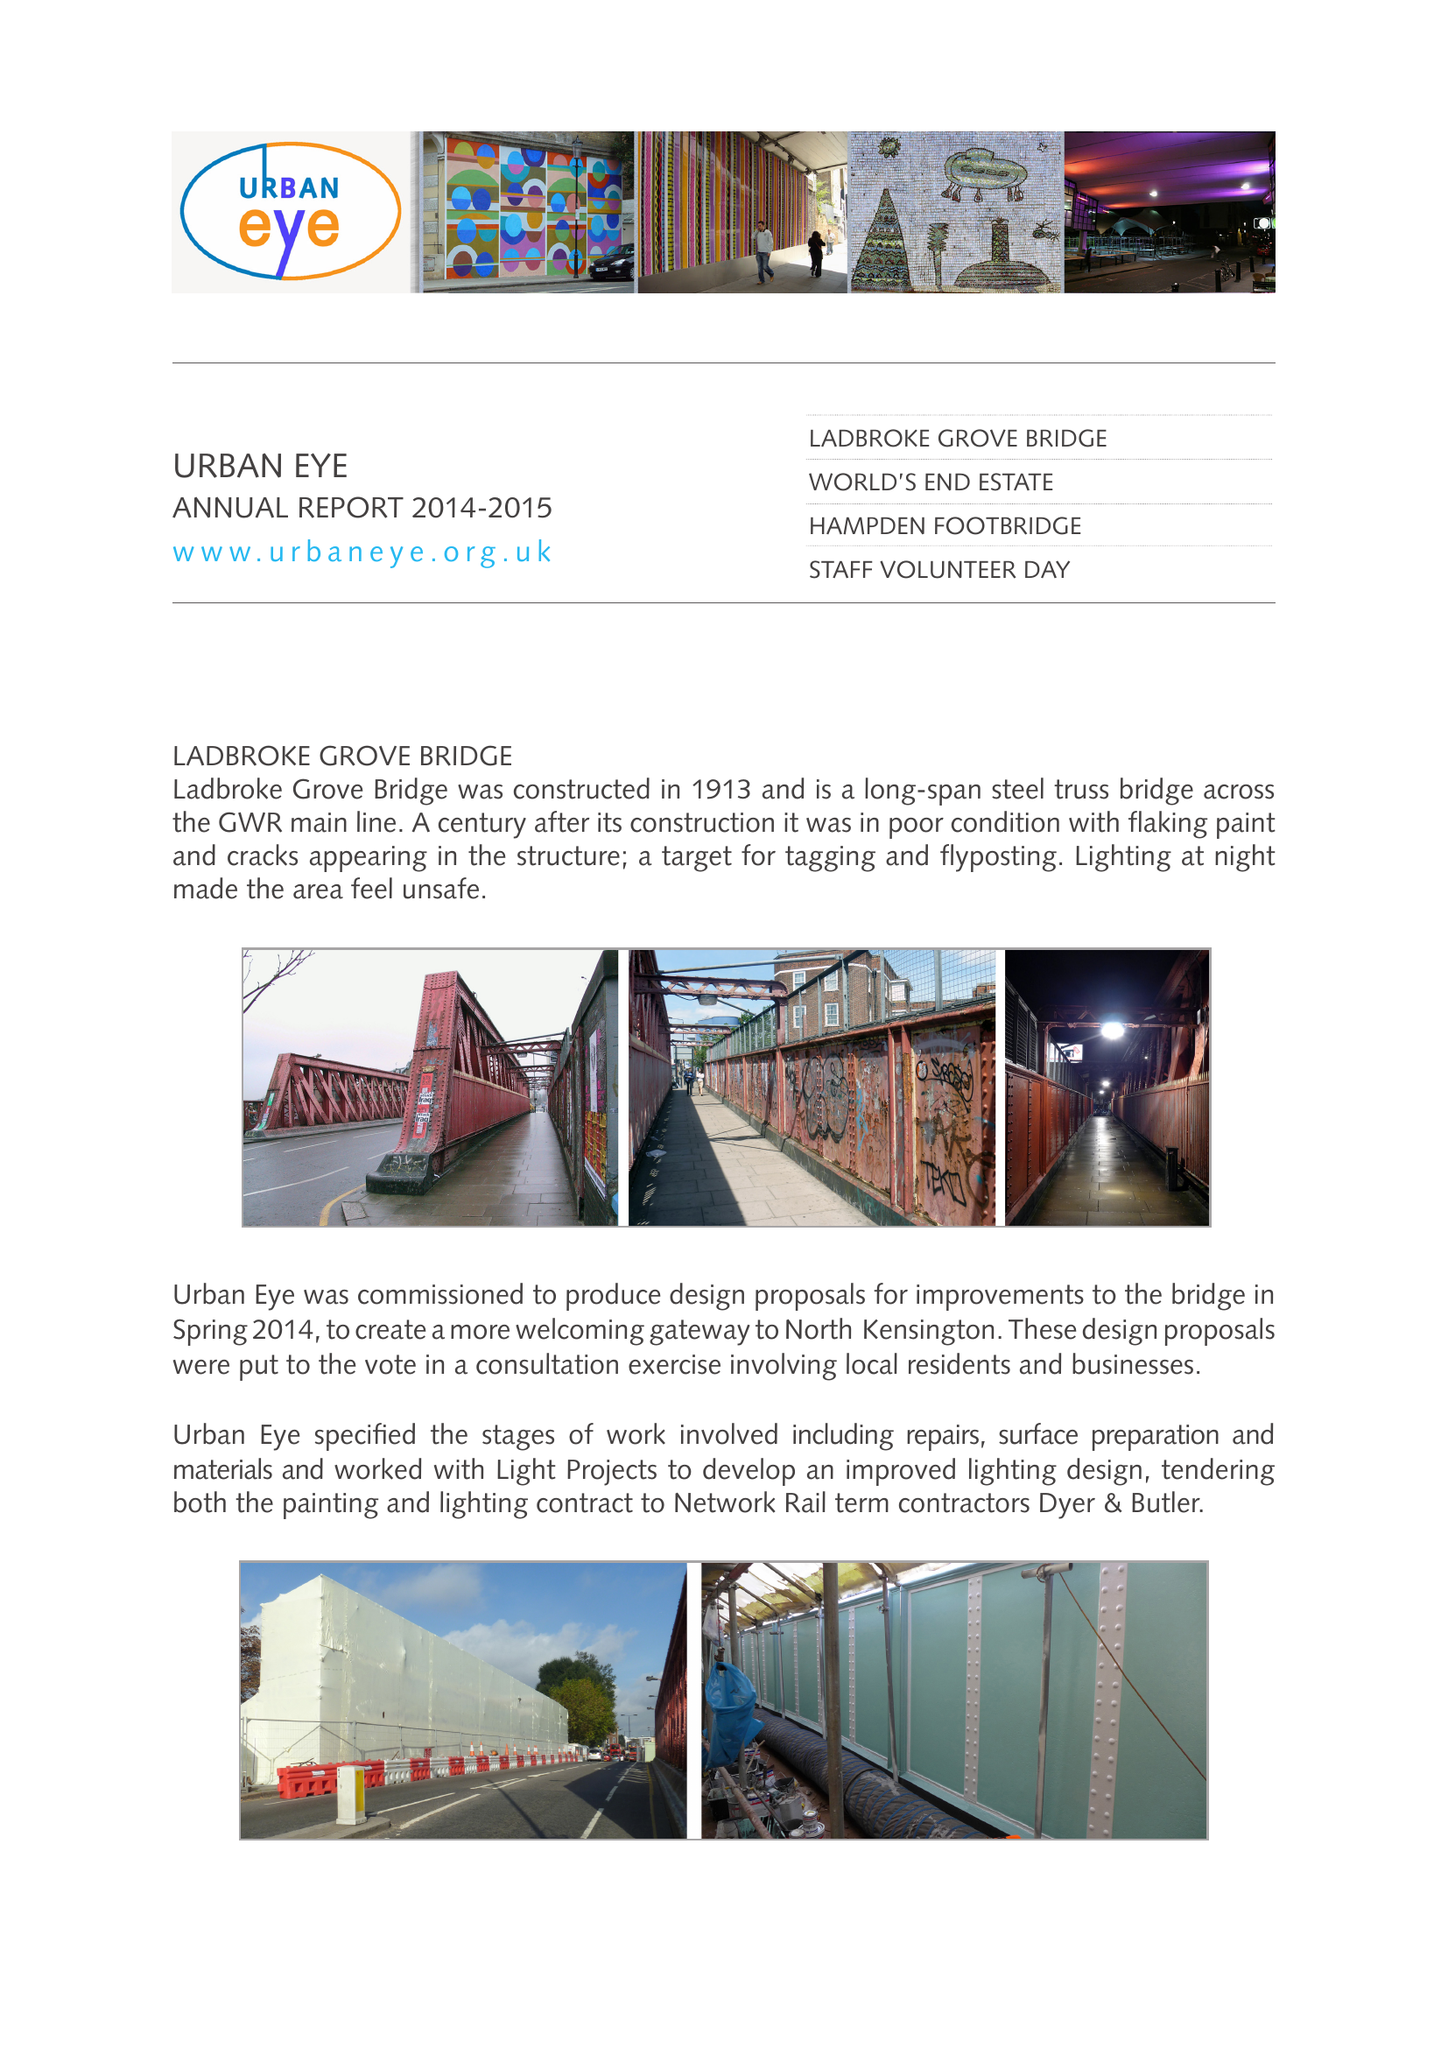What is the value for the address__street_line?
Answer the question using a single word or phrase. WHITCHURCH ROAD 